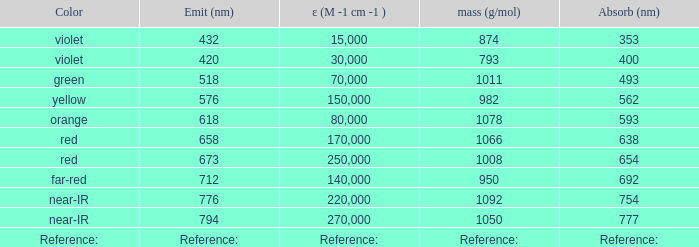Can you give me this table as a dict? {'header': ['Color', 'Emit (nm)', 'ε (M -1 cm -1 )', 'mass (g/mol)', 'Absorb (nm)'], 'rows': [['violet', '432', '15,000', '874', '353'], ['violet', '420', '30,000', '793', '400'], ['green', '518', '70,000', '1011', '493'], ['yellow', '576', '150,000', '982', '562'], ['orange', '618', '80,000', '1078', '593'], ['red', '658', '170,000', '1066', '638'], ['red', '673', '250,000', '1008', '654'], ['far-red', '712', '140,000', '950', '692'], ['near-IR', '776', '220,000', '1092', '754'], ['near-IR', '794', '270,000', '1050', '777'], ['Reference:', 'Reference:', 'Reference:', 'Reference:', 'Reference:']]} Which ε (M -1 cm -1) has a molar mass of 1008 g/mol? 250000.0. 